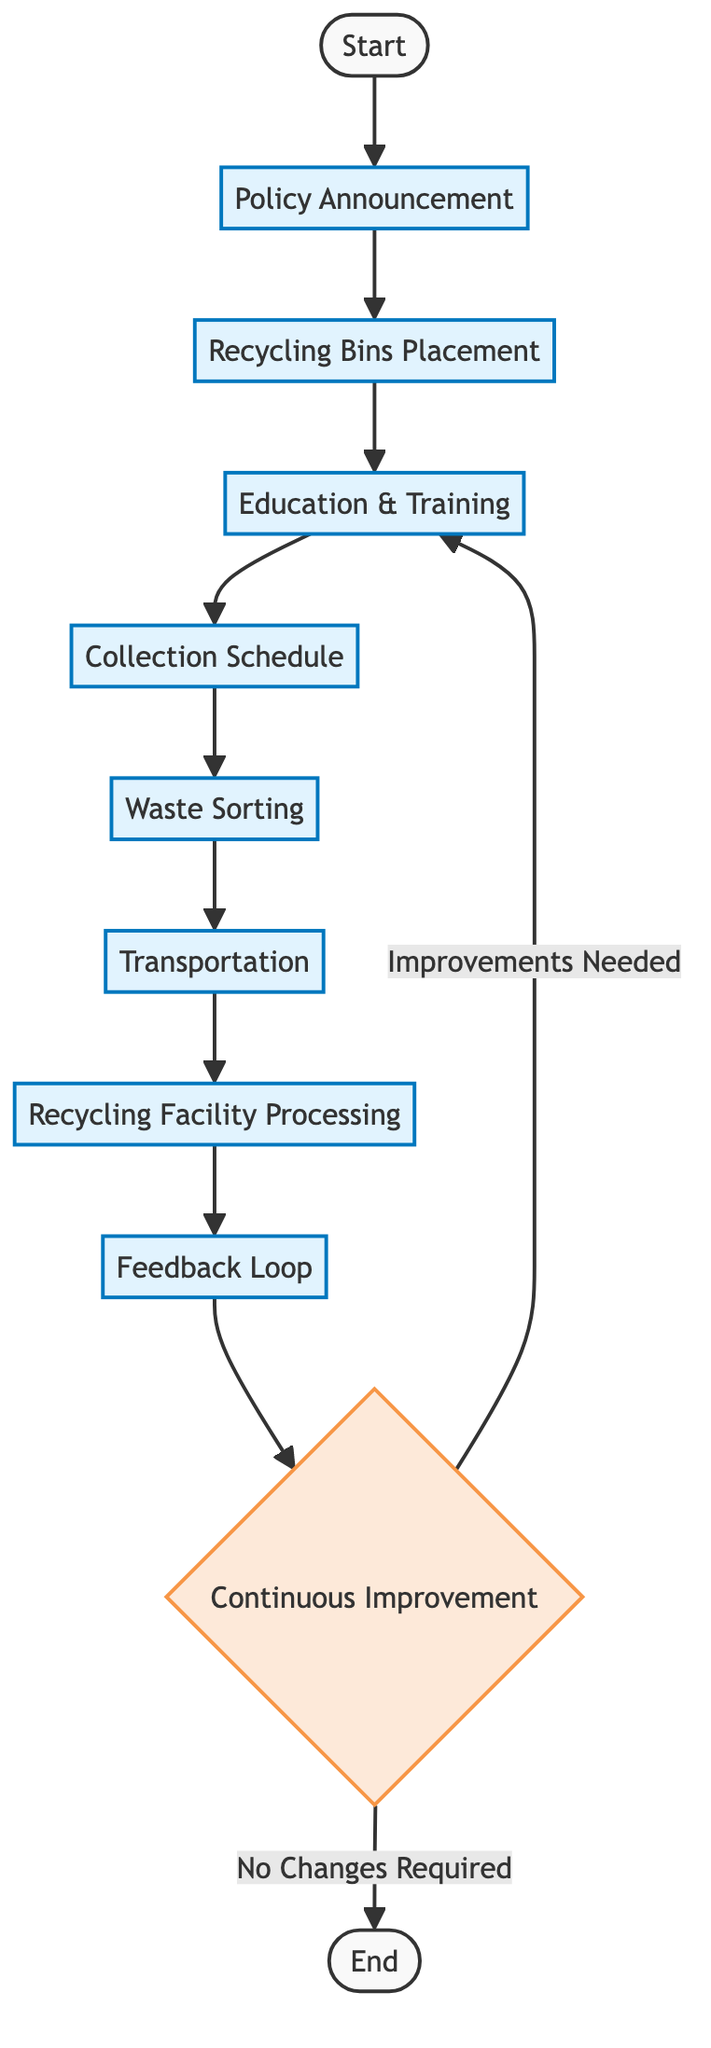What is the first step in the flow chart? The first step is "Start," which initiates the process outlined in the flow chart.
Answer: Start How many processes are there in the flow chart? The flow chart contains a total of seven processes: Policy Announcement, Recycling Bins Placement, Education & Training, Collection Schedule, Waste Sorting, Transportation, and Recycling Facility Processing.
Answer: Seven What is the last step before the flow chart ends? The last step before ending is the "Continuous Improvement" decision node, which determines if improvements are needed for the program.
Answer: Continuous Improvement What happens if improvements are needed according to the flow chart? If improvements are needed, the flow chart indicates that the flow returns to the "Education & Training" process for adjustments to be made.
Answer: Education & Training Which process follows the "Transportation" process? The process that follows "Transportation" is "Recycling Facility Processing," where the transported waste is processed.
Answer: Recycling Facility Processing Is there a feedback mechanism in the flow chart? Yes, there is a "Feedback Loop" process that receives feedback from the recycling facility regarding the collected plastics' quality and types.
Answer: Yes What action occurs after "Waste Sorting"? After "Waste Sorting," the subsequent action is "Transportation," where the sorted waste is transported to a local recycling facility.
Answer: Transportation Where does the flow go if "No Changes Required" is determined? If "No Changes Required" is determined, the flow goes to "End," concluding the process outlined in the flow chart.
Answer: End 